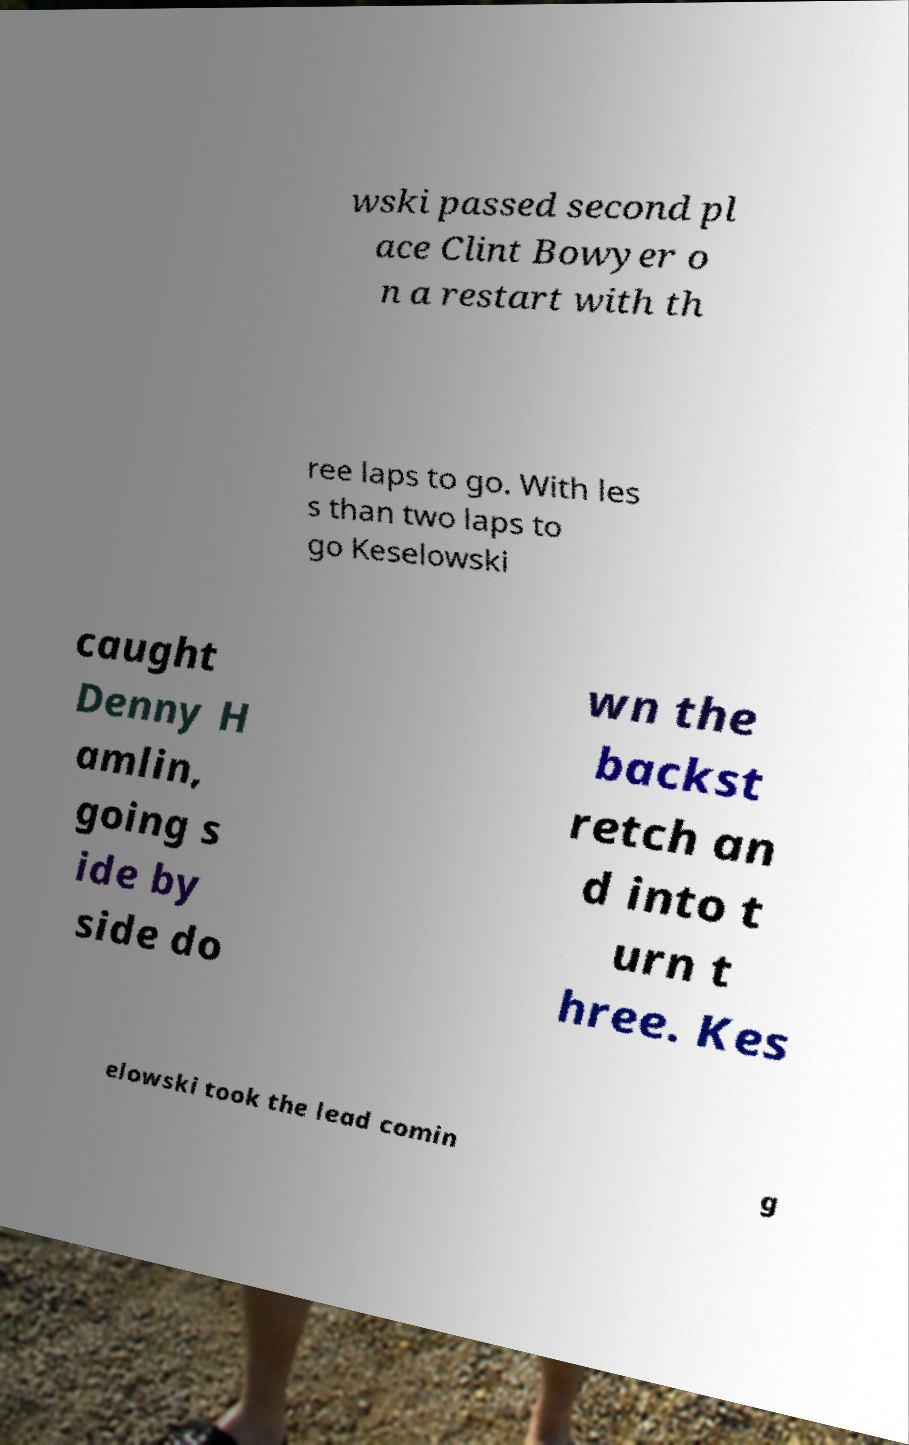For documentation purposes, I need the text within this image transcribed. Could you provide that? wski passed second pl ace Clint Bowyer o n a restart with th ree laps to go. With les s than two laps to go Keselowski caught Denny H amlin, going s ide by side do wn the backst retch an d into t urn t hree. Kes elowski took the lead comin g 